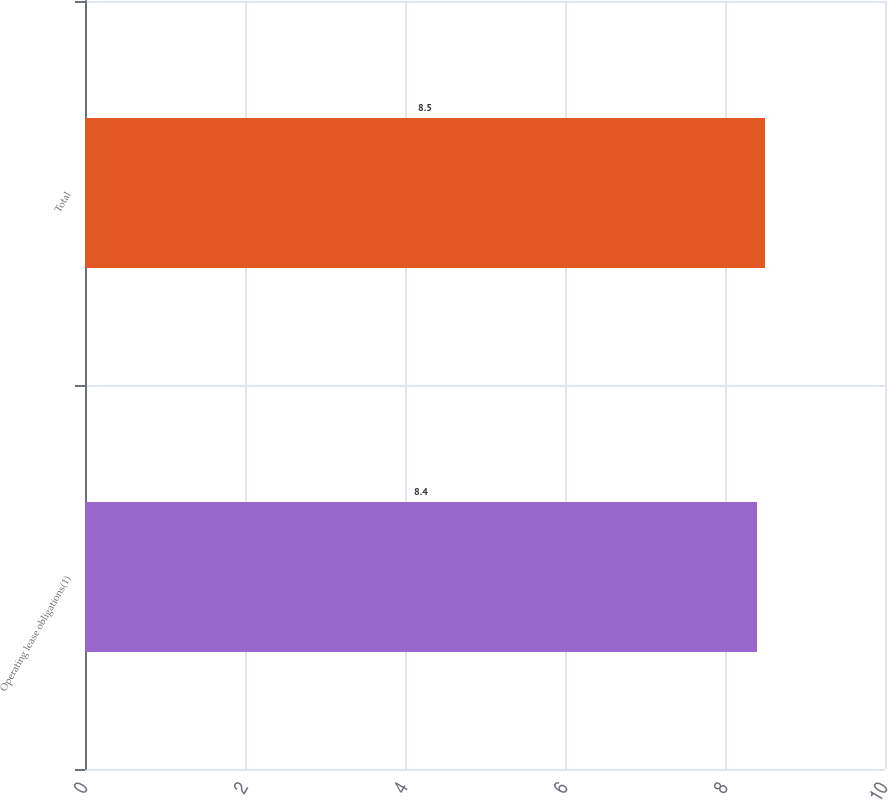Convert chart. <chart><loc_0><loc_0><loc_500><loc_500><bar_chart><fcel>Operating lease obligations(1)<fcel>Total<nl><fcel>8.4<fcel>8.5<nl></chart> 